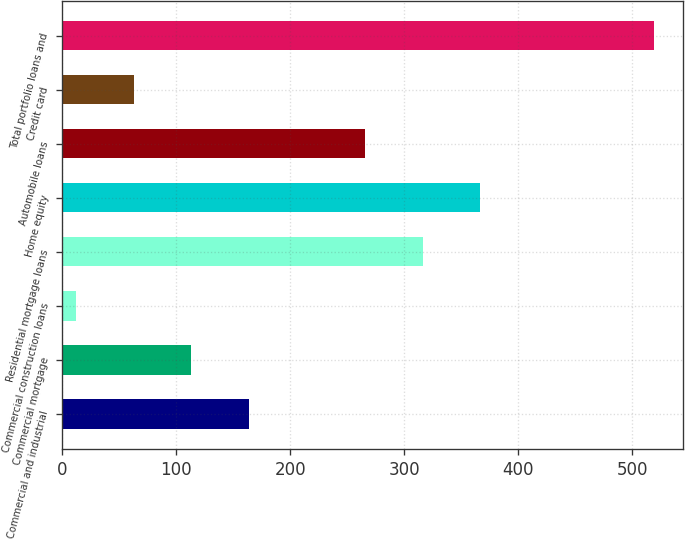Convert chart. <chart><loc_0><loc_0><loc_500><loc_500><bar_chart><fcel>Commercial and industrial<fcel>Commercial mortgage<fcel>Commercial construction loans<fcel>Residential mortgage loans<fcel>Home equity<fcel>Automobile loans<fcel>Credit card<fcel>Total portfolio loans and<nl><fcel>164.1<fcel>113.4<fcel>12<fcel>316.2<fcel>366.9<fcel>265.5<fcel>62.7<fcel>519<nl></chart> 